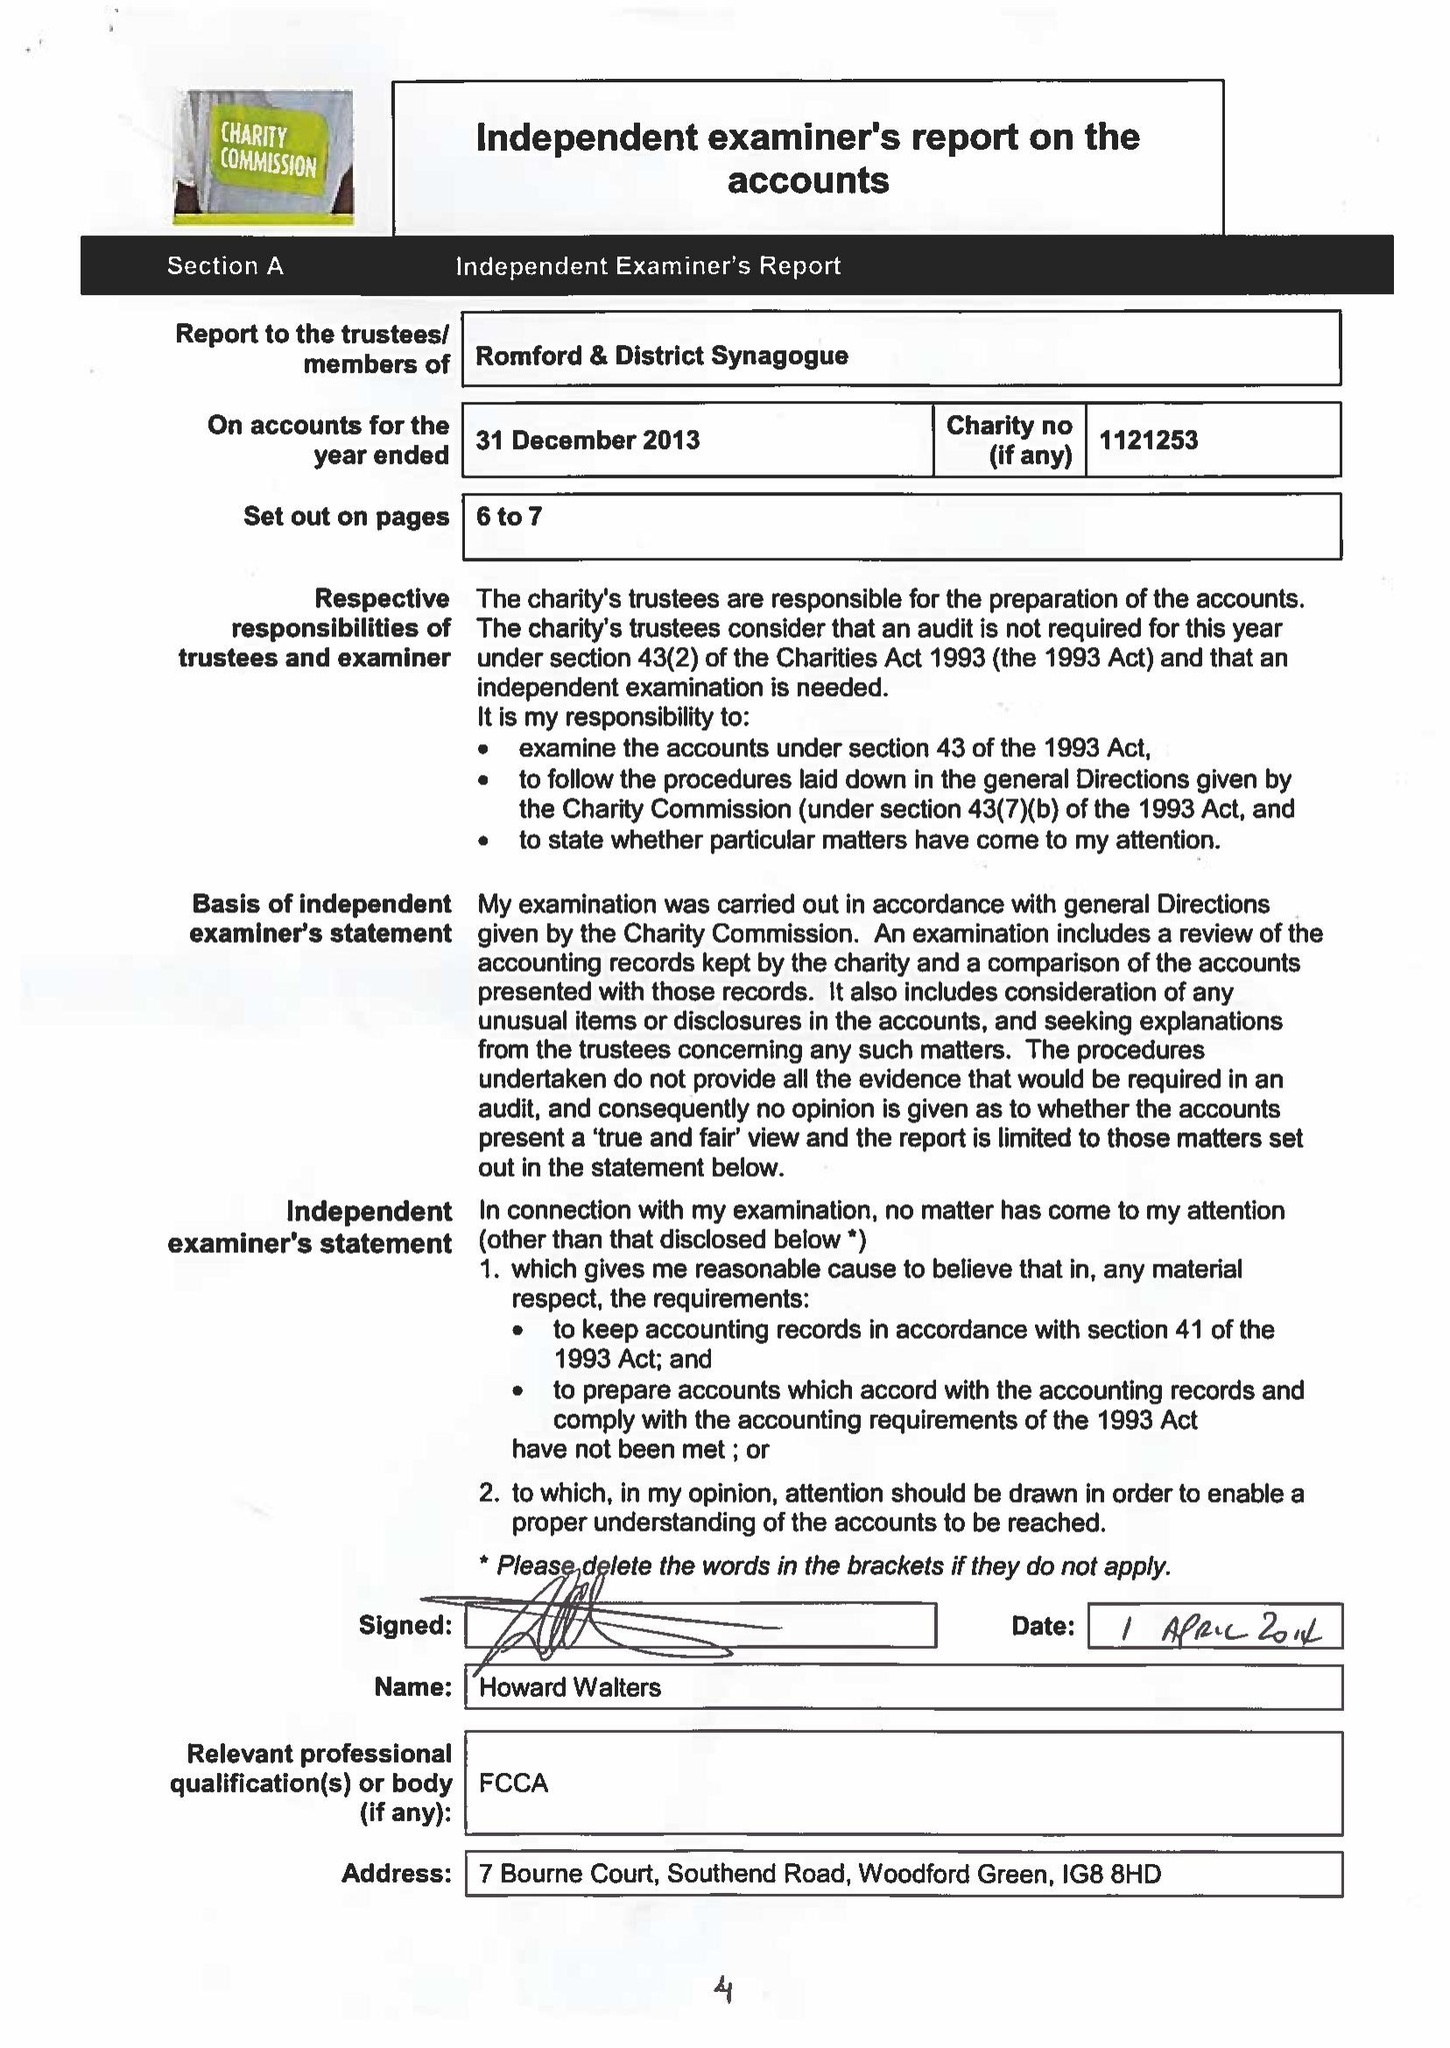What is the value for the address__street_line?
Answer the question using a single word or phrase. 25 EASTERN ROAD 